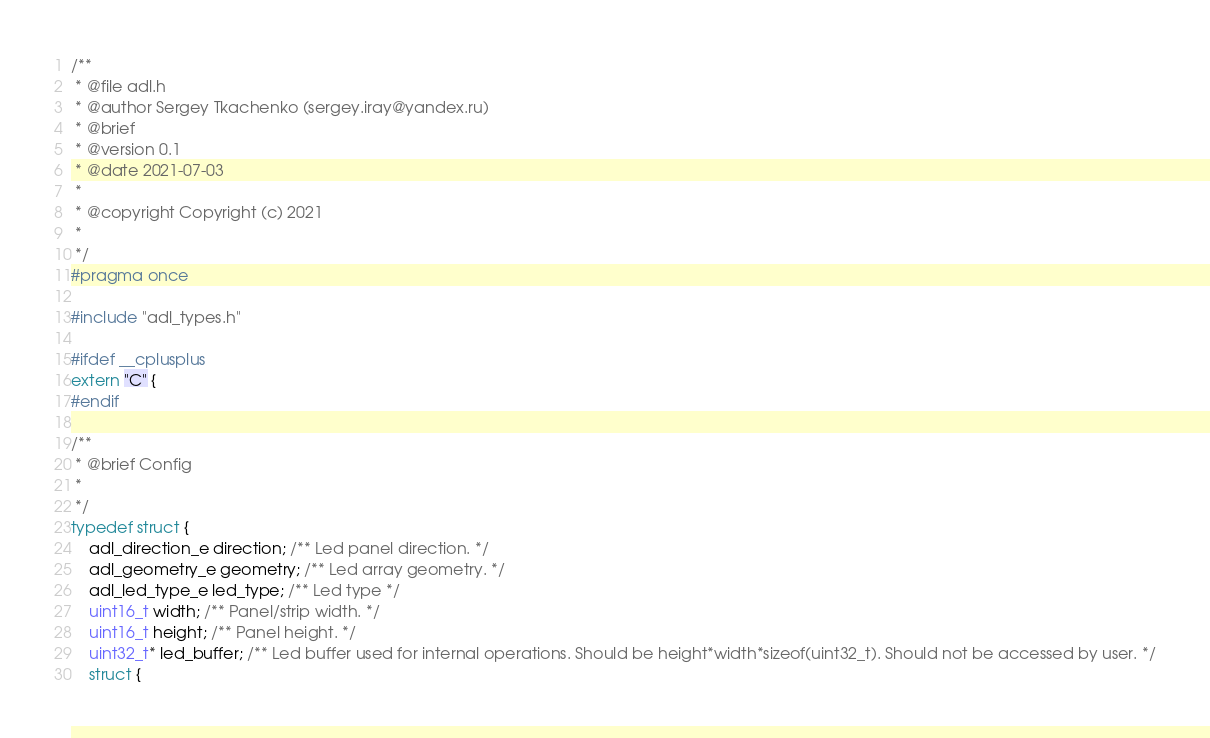Convert code to text. <code><loc_0><loc_0><loc_500><loc_500><_C_>/**
 * @file adl.h
 * @author Sergey Tkachenko (sergey.iray@yandex.ru)
 * @brief
 * @version 0.1
 * @date 2021-07-03
 *
 * @copyright Copyright (c) 2021
 *
 */
#pragma once

#include "adl_types.h"

#ifdef __cplusplus
extern "C" {
#endif

/**
 * @brief Config
 *
 */
typedef struct {
    adl_direction_e direction; /** Led panel direction. */
    adl_geometry_e geometry; /** Led array geometry. */
    adl_led_type_e led_type; /** Led type */
    uint16_t width; /** Panel/strip width. */
    uint16_t height; /** Panel height. */
    uint32_t* led_buffer; /** Led buffer used for internal operations. Should be height*width*sizeof(uint32_t). Should not be accessed by user. */
    struct {</code> 